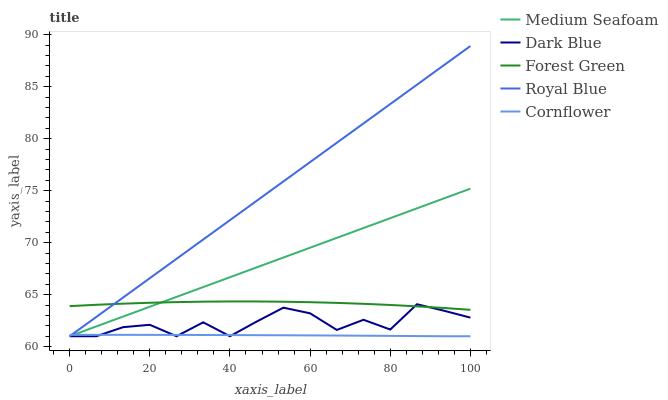Does Cornflower have the minimum area under the curve?
Answer yes or no. Yes. Does Royal Blue have the maximum area under the curve?
Answer yes or no. Yes. Does Forest Green have the minimum area under the curve?
Answer yes or no. No. Does Forest Green have the maximum area under the curve?
Answer yes or no. No. Is Royal Blue the smoothest?
Answer yes or no. Yes. Is Dark Blue the roughest?
Answer yes or no. Yes. Is Forest Green the smoothest?
Answer yes or no. No. Is Forest Green the roughest?
Answer yes or no. No. Does Dark Blue have the lowest value?
Answer yes or no. Yes. Does Forest Green have the lowest value?
Answer yes or no. No. Does Royal Blue have the highest value?
Answer yes or no. Yes. Does Forest Green have the highest value?
Answer yes or no. No. Is Cornflower less than Forest Green?
Answer yes or no. Yes. Is Forest Green greater than Cornflower?
Answer yes or no. Yes. Does Dark Blue intersect Forest Green?
Answer yes or no. Yes. Is Dark Blue less than Forest Green?
Answer yes or no. No. Is Dark Blue greater than Forest Green?
Answer yes or no. No. Does Cornflower intersect Forest Green?
Answer yes or no. No. 